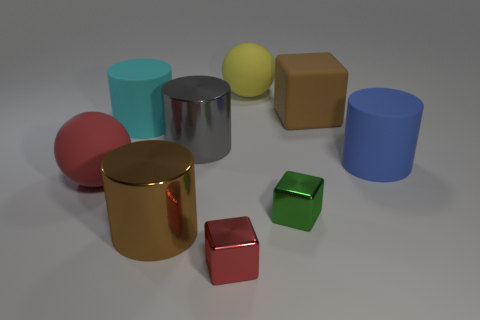Is the color of the sphere in front of the big gray metallic thing the same as the large matte cylinder that is behind the large blue rubber cylinder?
Keep it short and to the point. No. What number of large objects are left of the big yellow matte sphere and behind the blue rubber thing?
Your answer should be very brief. 2. How many other objects are the same shape as the blue thing?
Give a very brief answer. 3. Is the number of cubes that are on the left side of the cyan cylinder greater than the number of small brown spheres?
Offer a terse response. No. There is a large shiny cylinder in front of the big blue rubber cylinder; what color is it?
Offer a very short reply. Brown. The metallic cylinder that is the same color as the large matte cube is what size?
Keep it short and to the point. Large. What number of matte things are small yellow cylinders or big blue things?
Give a very brief answer. 1. There is a big ball left of the metal cylinder behind the large blue cylinder; is there a sphere behind it?
Offer a very short reply. Yes. There is a brown block; what number of tiny blocks are behind it?
Make the answer very short. 0. There is a thing that is the same color as the big matte cube; what is it made of?
Provide a succinct answer. Metal. 